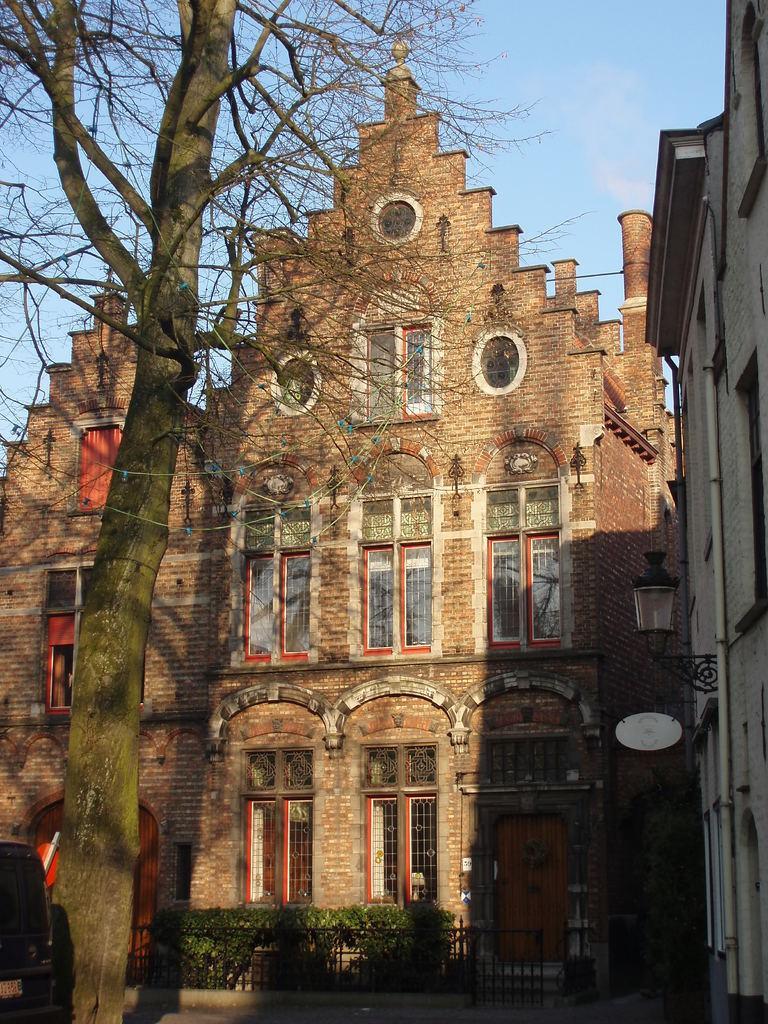Please provide a concise description of this image. In this image there is a tree, in the background there are buildings, plants and the sky. 